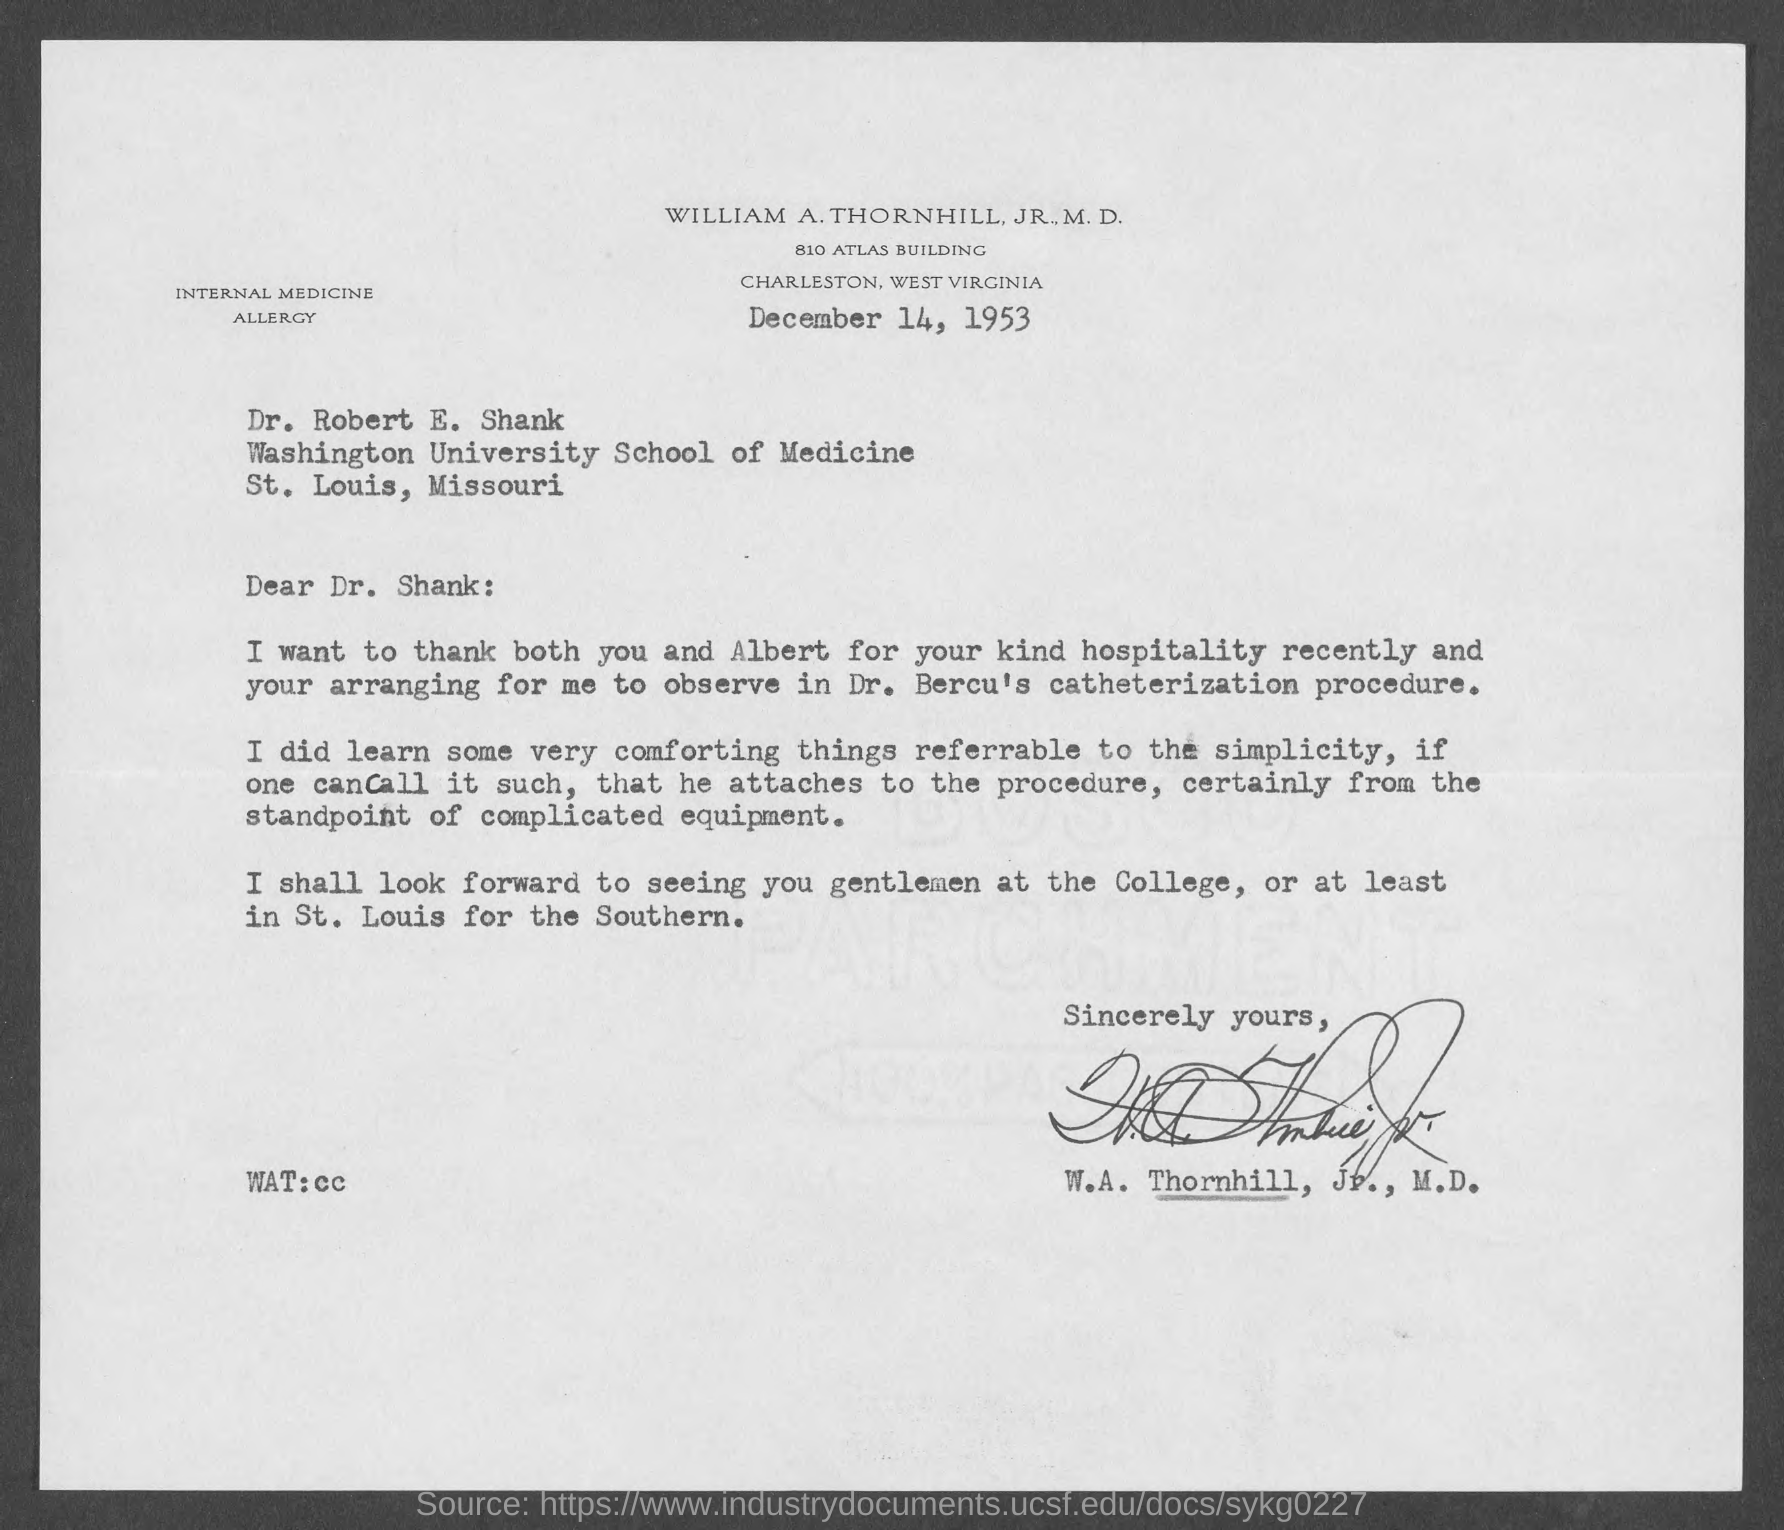On which date the letter is dated on?
Your answer should be compact. December 14, 1953. To whom is this letter written to?
Make the answer very short. Dr. Robert E. Shank. 